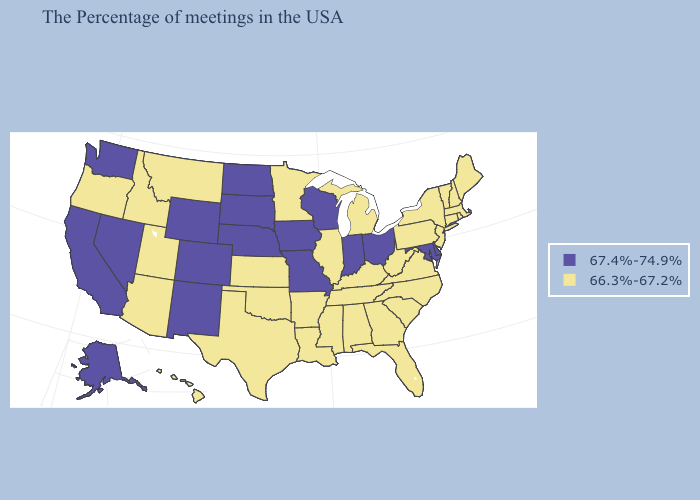What is the lowest value in the MidWest?
Answer briefly. 66.3%-67.2%. What is the value of Kentucky?
Concise answer only. 66.3%-67.2%. What is the value of Kentucky?
Write a very short answer. 66.3%-67.2%. Which states hav the highest value in the MidWest?
Concise answer only. Ohio, Indiana, Wisconsin, Missouri, Iowa, Nebraska, South Dakota, North Dakota. What is the lowest value in the MidWest?
Keep it brief. 66.3%-67.2%. Name the states that have a value in the range 66.3%-67.2%?
Quick response, please. Maine, Massachusetts, Rhode Island, New Hampshire, Vermont, Connecticut, New York, New Jersey, Pennsylvania, Virginia, North Carolina, South Carolina, West Virginia, Florida, Georgia, Michigan, Kentucky, Alabama, Tennessee, Illinois, Mississippi, Louisiana, Arkansas, Minnesota, Kansas, Oklahoma, Texas, Utah, Montana, Arizona, Idaho, Oregon, Hawaii. Name the states that have a value in the range 66.3%-67.2%?
Quick response, please. Maine, Massachusetts, Rhode Island, New Hampshire, Vermont, Connecticut, New York, New Jersey, Pennsylvania, Virginia, North Carolina, South Carolina, West Virginia, Florida, Georgia, Michigan, Kentucky, Alabama, Tennessee, Illinois, Mississippi, Louisiana, Arkansas, Minnesota, Kansas, Oklahoma, Texas, Utah, Montana, Arizona, Idaho, Oregon, Hawaii. What is the value of Maine?
Write a very short answer. 66.3%-67.2%. Name the states that have a value in the range 66.3%-67.2%?
Quick response, please. Maine, Massachusetts, Rhode Island, New Hampshire, Vermont, Connecticut, New York, New Jersey, Pennsylvania, Virginia, North Carolina, South Carolina, West Virginia, Florida, Georgia, Michigan, Kentucky, Alabama, Tennessee, Illinois, Mississippi, Louisiana, Arkansas, Minnesota, Kansas, Oklahoma, Texas, Utah, Montana, Arizona, Idaho, Oregon, Hawaii. Does Florida have a higher value than Georgia?
Be succinct. No. Name the states that have a value in the range 66.3%-67.2%?
Be succinct. Maine, Massachusetts, Rhode Island, New Hampshire, Vermont, Connecticut, New York, New Jersey, Pennsylvania, Virginia, North Carolina, South Carolina, West Virginia, Florida, Georgia, Michigan, Kentucky, Alabama, Tennessee, Illinois, Mississippi, Louisiana, Arkansas, Minnesota, Kansas, Oklahoma, Texas, Utah, Montana, Arizona, Idaho, Oregon, Hawaii. Name the states that have a value in the range 66.3%-67.2%?
Give a very brief answer. Maine, Massachusetts, Rhode Island, New Hampshire, Vermont, Connecticut, New York, New Jersey, Pennsylvania, Virginia, North Carolina, South Carolina, West Virginia, Florida, Georgia, Michigan, Kentucky, Alabama, Tennessee, Illinois, Mississippi, Louisiana, Arkansas, Minnesota, Kansas, Oklahoma, Texas, Utah, Montana, Arizona, Idaho, Oregon, Hawaii. Does the map have missing data?
Give a very brief answer. No. What is the highest value in the USA?
Give a very brief answer. 67.4%-74.9%. 